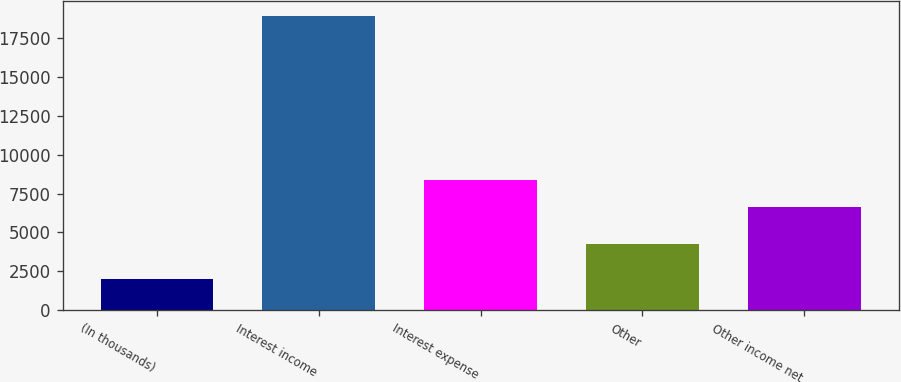Convert chart. <chart><loc_0><loc_0><loc_500><loc_500><bar_chart><fcel>(In thousands)<fcel>Interest income<fcel>Interest expense<fcel>Other<fcel>Other income net<nl><fcel>2017<fcel>18933<fcel>8349.6<fcel>4263<fcel>6658<nl></chart> 